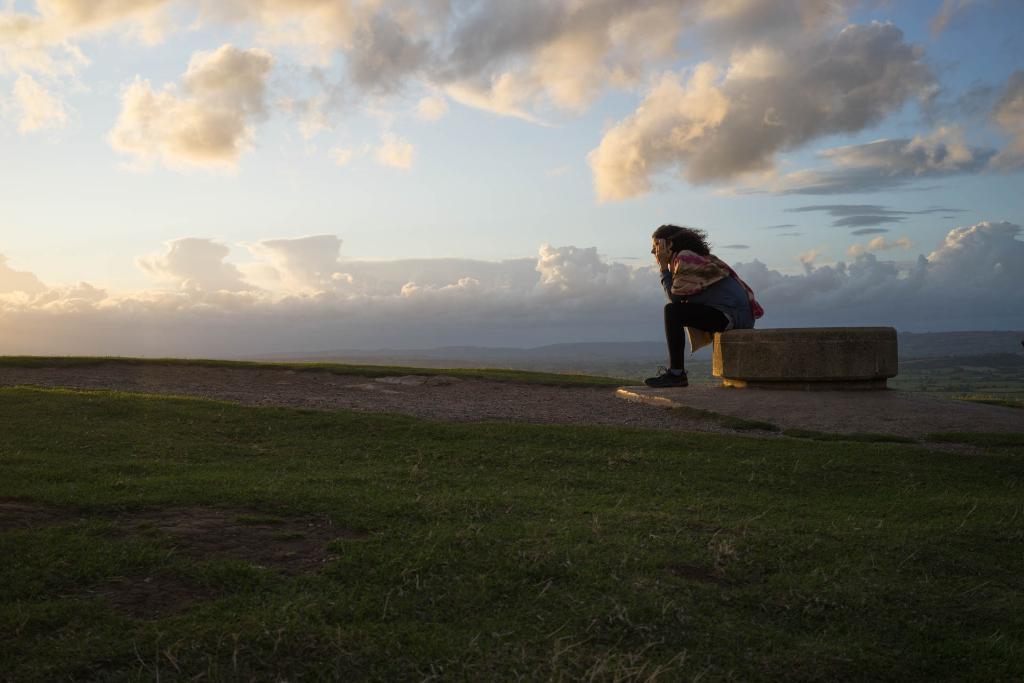Could you give a brief overview of what you see in this image? There is a person sitting on surface and we can see grass and sky with clouds. 